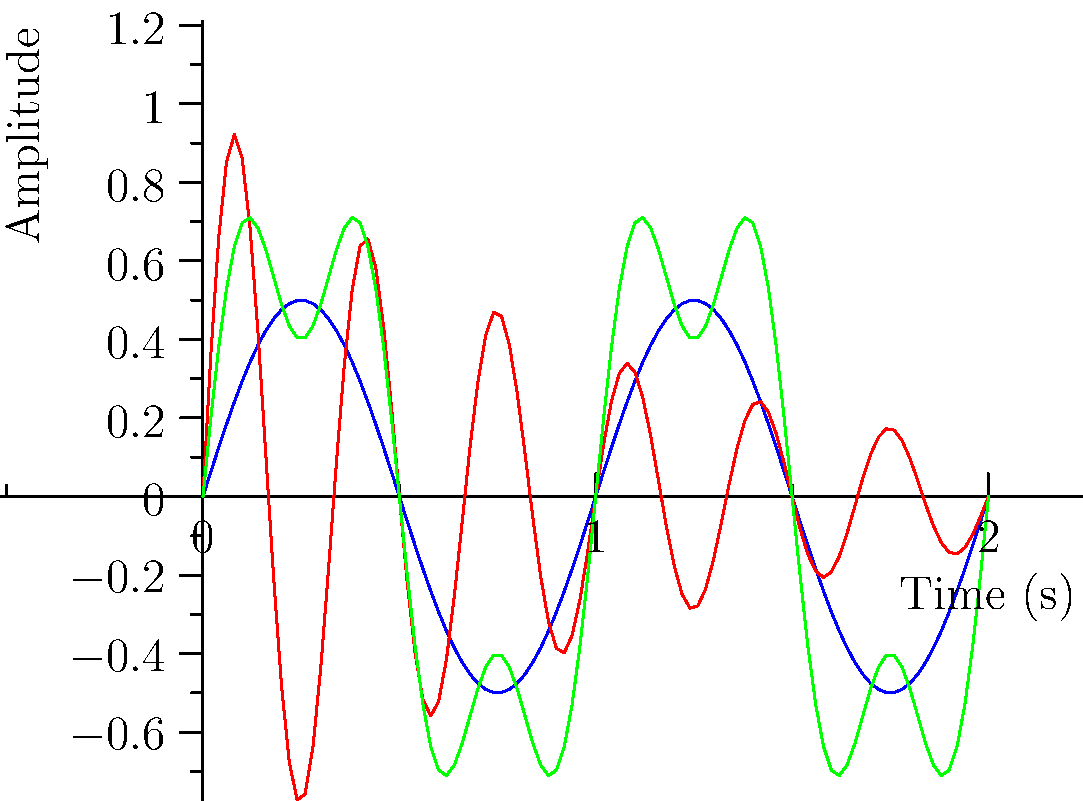Analyzing the waveforms shown in the graph, which instrument is likely to have the most complex harmonic structure and why? To answer this question, we need to analyze the waveforms of each instrument:

1. Piano (blue): This waveform shows a simple sinusoidal pattern, indicating a relatively pure tone with fewer harmonics.

2. Guitar (red): This waveform exhibits a decaying amplitude over time (envelope) and appears to have a more complex pattern than the piano, suggesting the presence of more harmonics.

3. Violin (green): This waveform shows a combination of two different frequencies (visible in the beating pattern), indicating a more complex harmonic structure.

To determine which instrument has the most complex harmonic structure, we need to consider:

a) The number of visible frequency components
b) The complexity of the waveform pattern
c) The presence of additional features like decay or beating

The violin waveform clearly shows a combination of at least two distinct frequencies, creating a more complex pattern than either the piano or guitar. This suggests that the violin has a richer harmonic content, as it's combining multiple frequencies in its sound.

While the guitar shows some complexity with its decay pattern, it doesn't exhibit the same level of frequency interaction as the violin.

The piano, having the simplest waveform, likely has the least complex harmonic structure of the three.

Therefore, based on the given waveforms, the violin appears to have the most complex harmonic structure due to its visible combination of multiple frequencies.
Answer: Violin, due to visible combination of multiple frequencies in its waveform. 